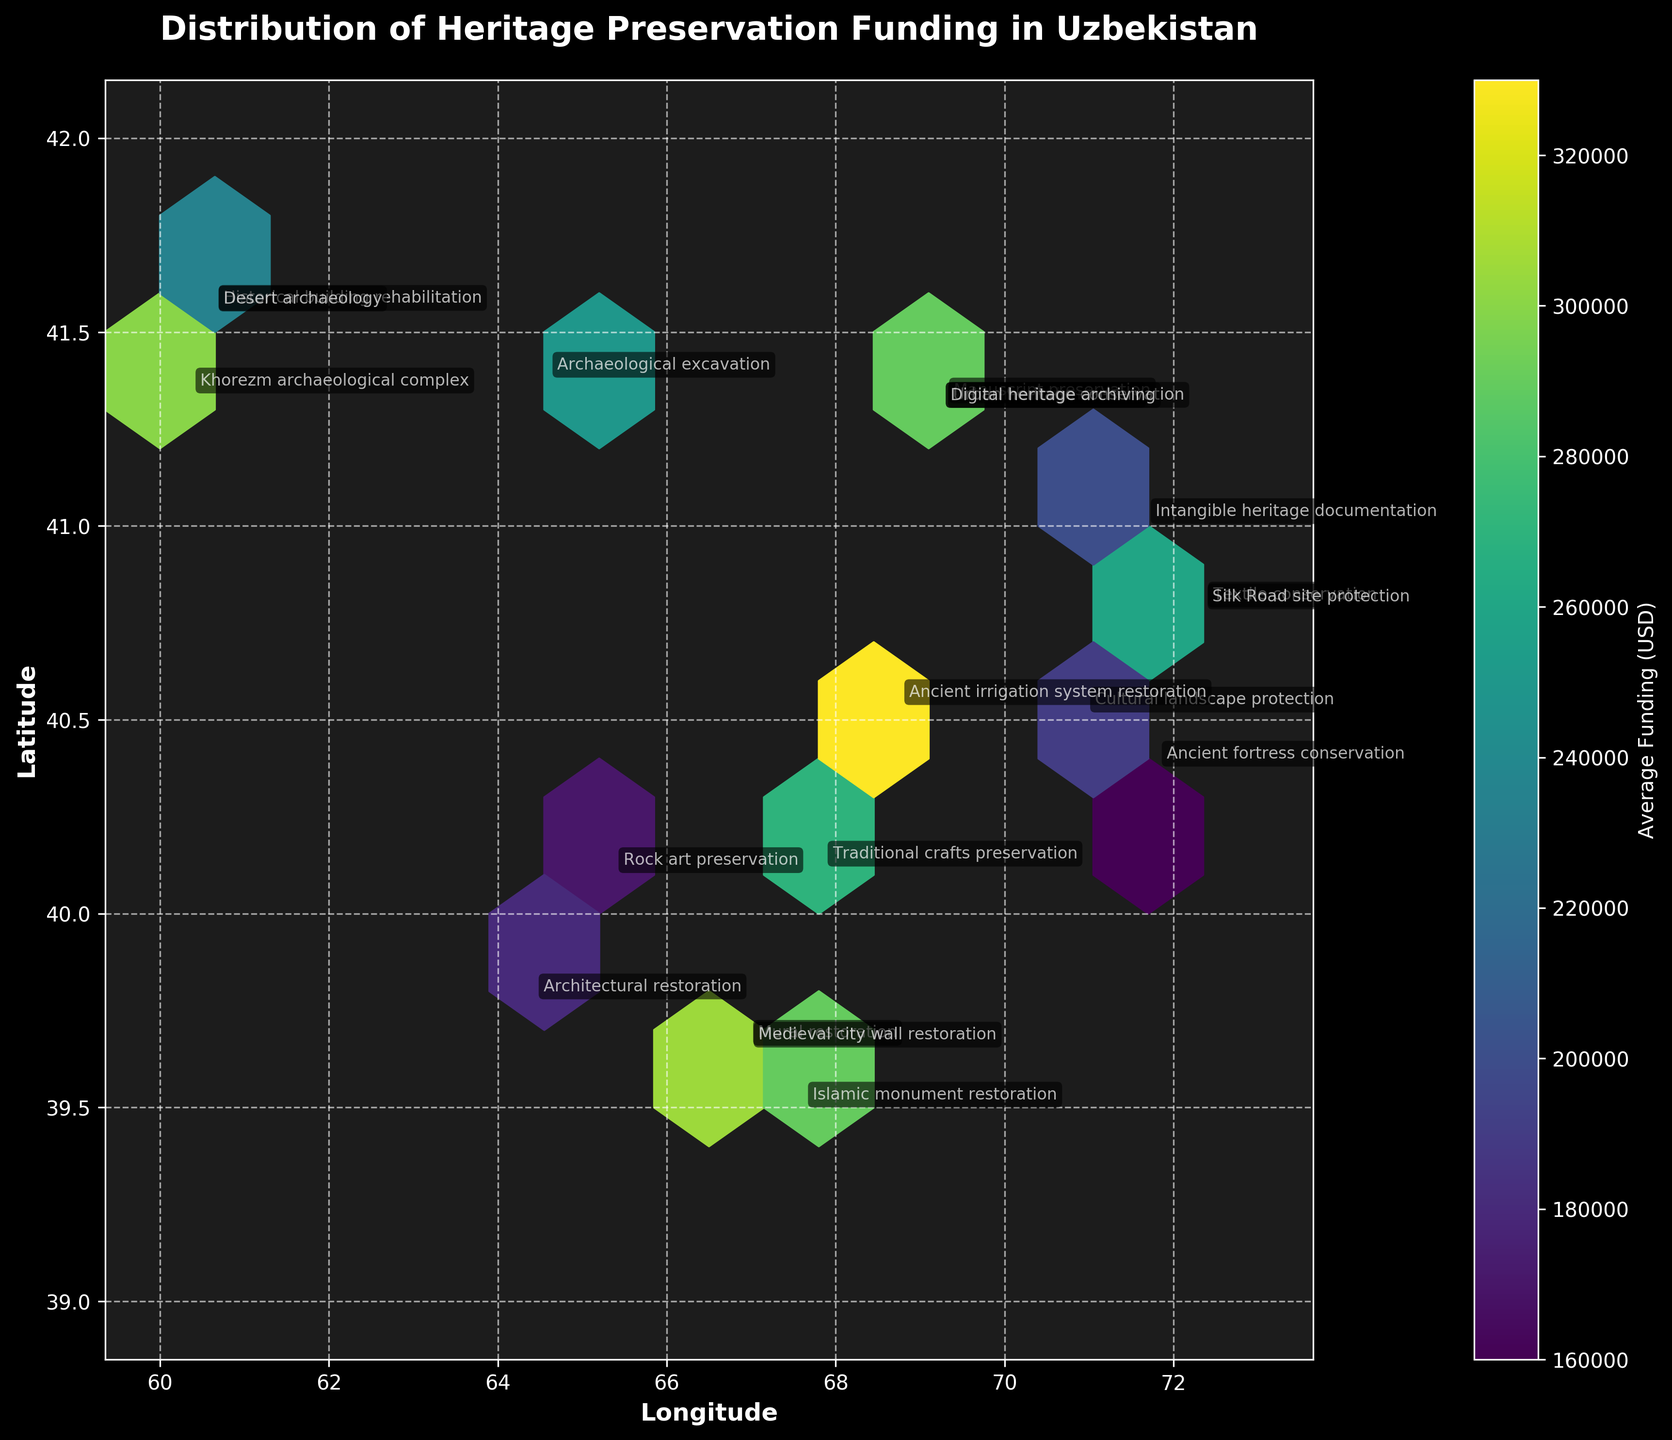What is the title of the plot? The title of the plot is usually found at the top of the chart. In this case, it should clearly state what the plot is about.
Answer: Distribution of Heritage Preservation Funding in Uzbekistan What do the axes represent? The labels on the horizontal and vertical axes provide this information. Here, the horizontal axis represents Longitude, and the vertical axis represents Latitude.
Answer: Longitude and Latitude What does the color bar indicate? The color bar is usually found on the side of the plot and shows the range of colors corresponding to different average funding levels.
Answer: Average Funding (USD) How are the data points visually represented on the Hexbin Plot? The data points are represented using hexagonal bins. The color intensity of these bins represents the average funding amount.
Answer: Hexagonal bins with color intensity Which geographic location has the highest average funding based on the color intensity? By identifying the hexagon with the most intense color on the plot, we can determine the location with the highest funding.
Answer: The hexagon around coordinates (69.24, 41.2995) What is the approximate range of average funding represented on the color bar? You can derive the range from the labels on the color bar on the side of the plot.
Answer: From around 150,000 to 350,000 USD Are there any specific project types mentioned at coordinates (69.2401, 41.2995)? To find this, we look at the annotations on the plot near those coordinates.
Answer: Museum modernization and Digital heritage archiving Which project type is associated with the highest funding based on annotations? By looking at the annotation with the corresponding hexagon with the most intense color, we can find this information.
Answer: Digital heritage archiving Which region has the most diverse types of heritage protection projects? By examining which area has a higher density of different annotations, we can determine this.
Answer: Around coordinates (69.2401, 41.2995) Can you identify any regions where the average funding is relatively low? This involves identifying hexagons with a less intense color, indicating lower funding levels.
Answer: Around coordinates (71.7978, 40.3744) 